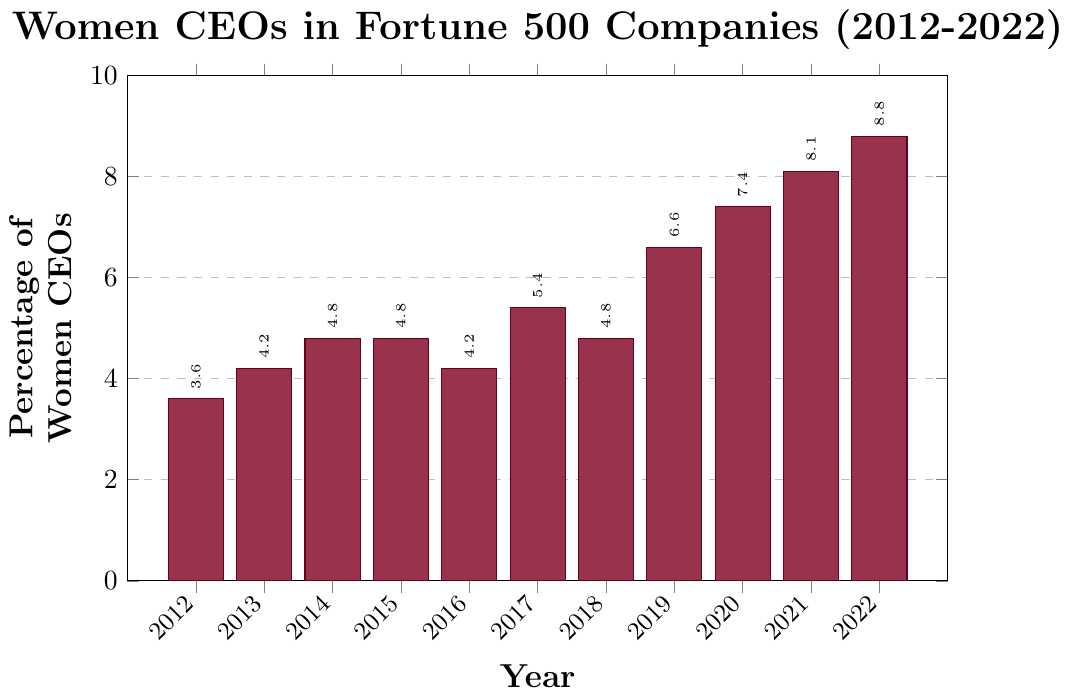What's the percentage increase in Women CEOs from 2012 to 2022? Subtract the percentage in 2012 from the percentage in 2022: 8.8 - 3.6 = 5.2. The percentage increase is 5.2%.
Answer: 5.2% Which year had the highest percentage of Women CEOs? Identify the year with the highest bar in the plot, which is annotated as 2022 with 8.8%.
Answer: 2022 Did the percentage of Women CEOs increase or decrease from 2014 to 2015? Compare the heights of the bars for 2014 (4.8%) and 2015 (4.8%). Both are the same, indicating no change.
Answer: No change What is the average percentage of Women CEOs across all years? Sum the percentages for all years and divide by the number of years. (3.6 + 4.2 + 4.8 + 4.8 + 4.2 + 5.4 + 4.8 + 6.6 + 7.4 + 8.1 + 8.8) = 62.7. Divide 62.7 by 11 to get the average: 62.7 / 11 ≈ 5.7%.
Answer: 5.7% Between which two consecutive years is the largest increase in the percentage of Women CEOs observed? Calculate the differences between each consecutive year and identify the largest one: 2012 to 2013 (+0.6), 2013 to 2014 (+0.6), 2014 to 2015 (0), 2015 to 2016 (-0.6), 2016 to 2017 (+1.2), 2017 to 2018 (-0.6), 2018 to 2019 (+1.8), 2019 to 2020 (+0.8), 2020 to 2021 (+0.7), 2021 to 2022 (+0.7). The largest increase is from 2018 to 2019 (+1.8).
Answer: 2018 to 2019 How many years had a percentage of Women CEOs below 5%? Count the years with percentages below 5%: 2012 (3.6), 2013 (4.2), 2014 (4.8), 2015 (4.8), 2016 (4.2), 2018 (4.8). There are 6 such years.
Answer: 6 During which year(s) did the percentage remain unchanged compared to the previous year? Identify the years where the bar heights are the same as the previous year: 2014 (4.8) and 2015 (4.8).
Answer: 2015 Compared to 2016, how much higher was the percentage of Women CEOs in 2022? Subtract the 2016 percentage from the 2022 percentage: 8.8 - 4.2 = 4.6.
Answer: 4.6 Which year had a percentage equal to the median percentage over the entire period? Arrange the percentages in ascending order and find the median (middle value): 3.6, 4.2, 4.2, 4.8, 4.8, 4.8, 5.4, 6.6, 7.4, 8.1, 8.8. The median is 4.8, which occurred in 2014, 2015, and 2018.
Answer: 2014, 2015, 2018 